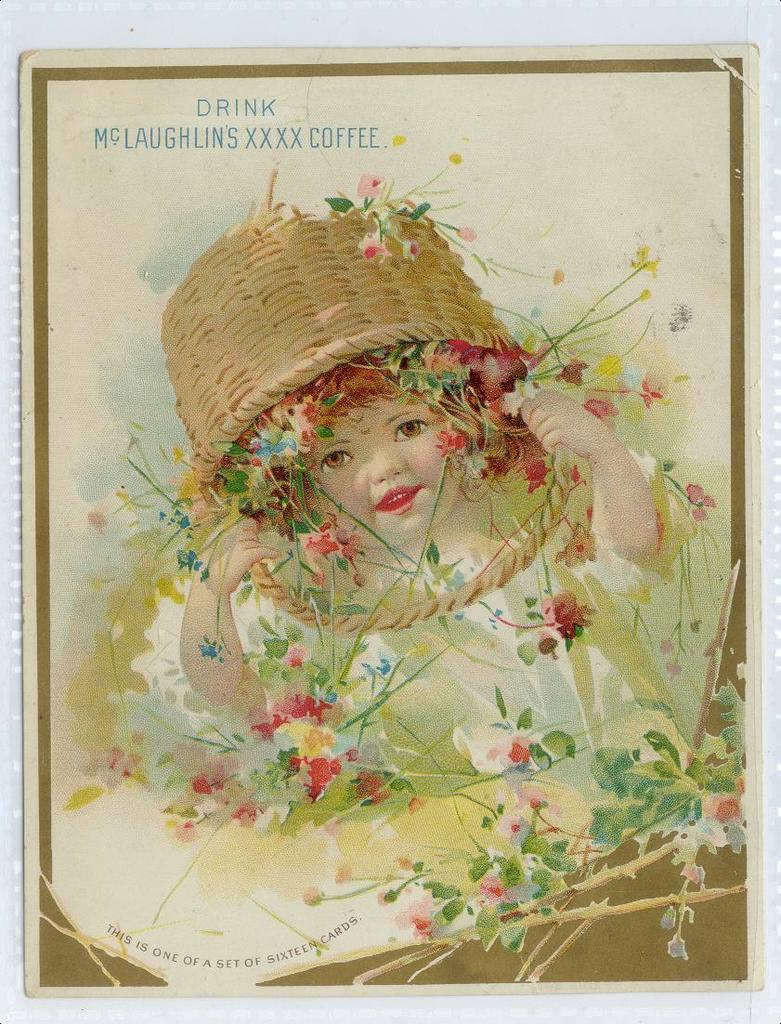What is the main subject of the image? The main subject of the image is an art of a baby. What is on the baby's head in the image? There is a flower basket on the baby's head in the image. What color is the background of the image? The background color of the image is white. What might be the purpose of the image? The image might be a photo frame. What type of milk is being used as bait for the horses in the image? There are no horses or milk present in the image; it features an art of a baby with a flower basket on its head. 